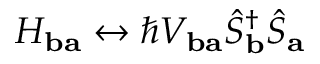<formula> <loc_0><loc_0><loc_500><loc_500>H _ { b a } \leftrightarrow \hbar { V } _ { b a } \hat { S } _ { b } ^ { \dagger } \hat { S } _ { a }</formula> 